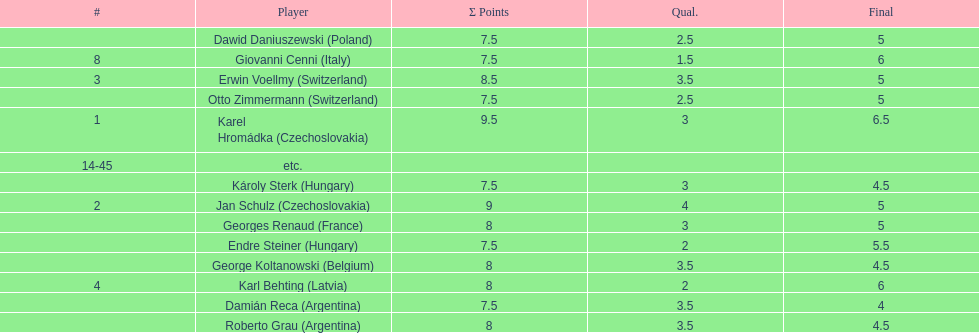Who was the top scorer from switzerland? Erwin Voellmy. 